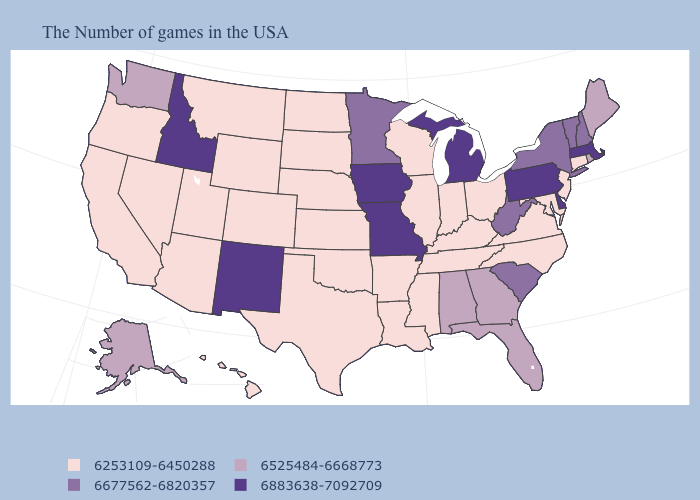Does the map have missing data?
Concise answer only. No. How many symbols are there in the legend?
Keep it brief. 4. Does Kansas have the lowest value in the USA?
Keep it brief. Yes. Does North Dakota have the same value as Mississippi?
Concise answer only. Yes. Which states have the lowest value in the West?
Give a very brief answer. Wyoming, Colorado, Utah, Montana, Arizona, Nevada, California, Oregon, Hawaii. Name the states that have a value in the range 6253109-6450288?
Answer briefly. Connecticut, New Jersey, Maryland, Virginia, North Carolina, Ohio, Kentucky, Indiana, Tennessee, Wisconsin, Illinois, Mississippi, Louisiana, Arkansas, Kansas, Nebraska, Oklahoma, Texas, South Dakota, North Dakota, Wyoming, Colorado, Utah, Montana, Arizona, Nevada, California, Oregon, Hawaii. Does Massachusetts have the lowest value in the USA?
Keep it brief. No. What is the value of Ohio?
Concise answer only. 6253109-6450288. Does Kentucky have the highest value in the South?
Answer briefly. No. Does the first symbol in the legend represent the smallest category?
Quick response, please. Yes. How many symbols are there in the legend?
Give a very brief answer. 4. What is the value of Maryland?
Be succinct. 6253109-6450288. What is the value of Wisconsin?
Keep it brief. 6253109-6450288. Name the states that have a value in the range 6677562-6820357?
Keep it brief. New Hampshire, Vermont, New York, South Carolina, West Virginia, Minnesota. Which states have the lowest value in the West?
Quick response, please. Wyoming, Colorado, Utah, Montana, Arizona, Nevada, California, Oregon, Hawaii. 